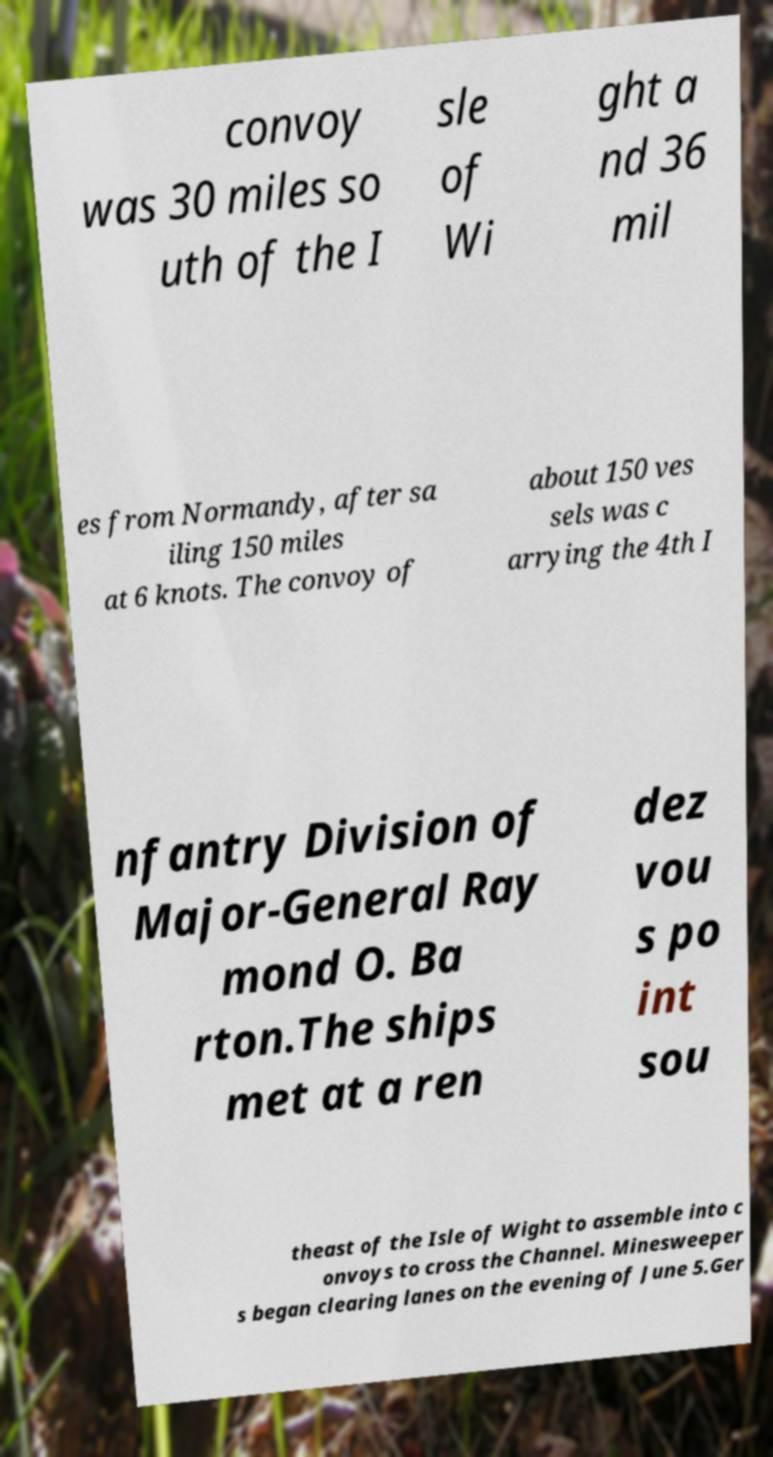Could you extract and type out the text from this image? convoy was 30 miles so uth of the I sle of Wi ght a nd 36 mil es from Normandy, after sa iling 150 miles at 6 knots. The convoy of about 150 ves sels was c arrying the 4th I nfantry Division of Major-General Ray mond O. Ba rton.The ships met at a ren dez vou s po int sou theast of the Isle of Wight to assemble into c onvoys to cross the Channel. Minesweeper s began clearing lanes on the evening of June 5.Ger 